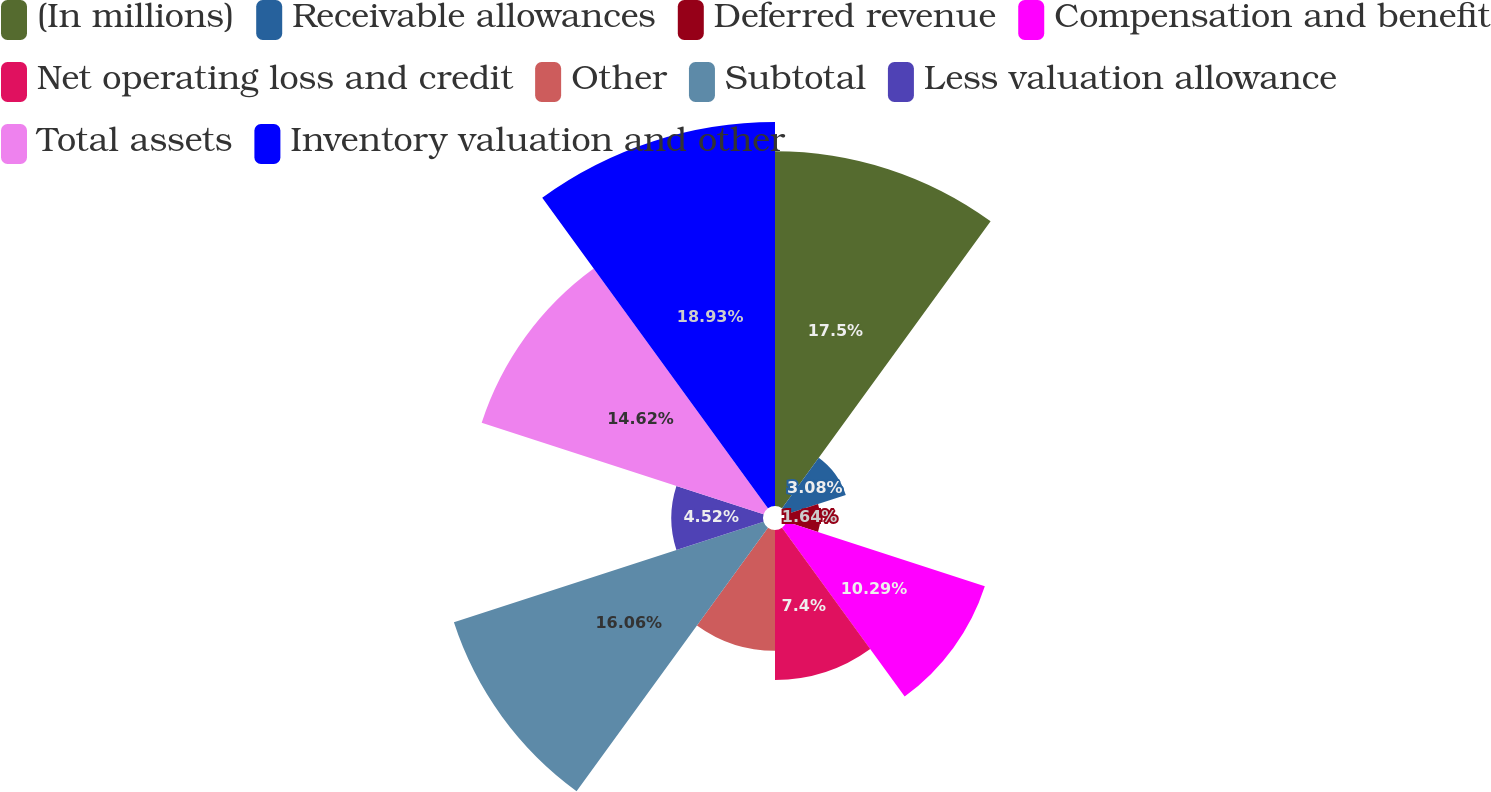<chart> <loc_0><loc_0><loc_500><loc_500><pie_chart><fcel>(In millions)<fcel>Receivable allowances<fcel>Deferred revenue<fcel>Compensation and benefit<fcel>Net operating loss and credit<fcel>Other<fcel>Subtotal<fcel>Less valuation allowance<fcel>Total assets<fcel>Inventory valuation and other<nl><fcel>17.5%<fcel>3.08%<fcel>1.64%<fcel>10.29%<fcel>7.4%<fcel>5.96%<fcel>16.06%<fcel>4.52%<fcel>14.62%<fcel>18.94%<nl></chart> 